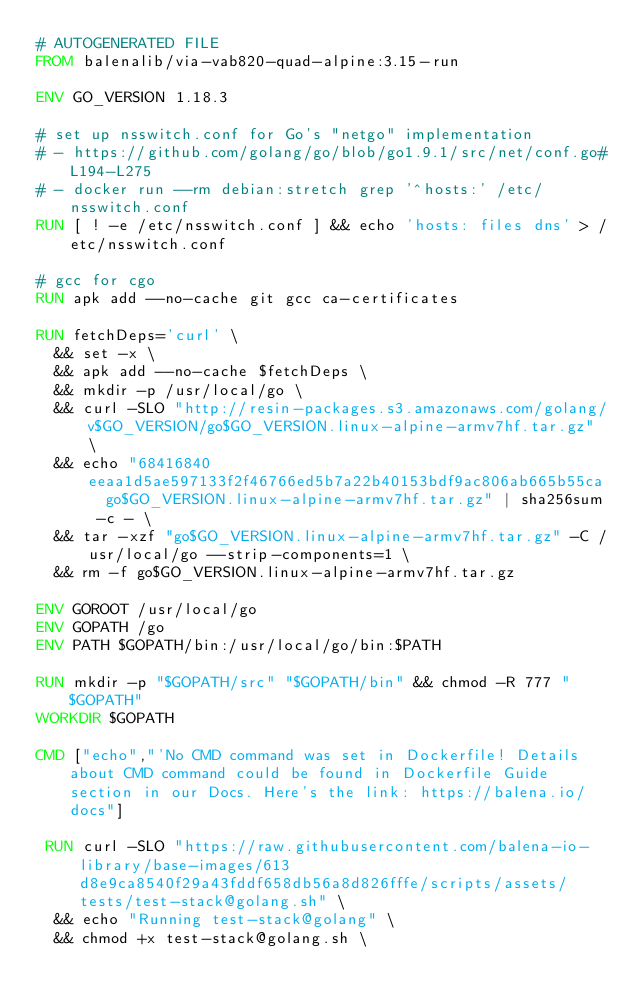Convert code to text. <code><loc_0><loc_0><loc_500><loc_500><_Dockerfile_># AUTOGENERATED FILE
FROM balenalib/via-vab820-quad-alpine:3.15-run

ENV GO_VERSION 1.18.3

# set up nsswitch.conf for Go's "netgo" implementation
# - https://github.com/golang/go/blob/go1.9.1/src/net/conf.go#L194-L275
# - docker run --rm debian:stretch grep '^hosts:' /etc/nsswitch.conf
RUN [ ! -e /etc/nsswitch.conf ] && echo 'hosts: files dns' > /etc/nsswitch.conf

# gcc for cgo
RUN apk add --no-cache git gcc ca-certificates

RUN fetchDeps='curl' \
	&& set -x \
	&& apk add --no-cache $fetchDeps \
	&& mkdir -p /usr/local/go \
	&& curl -SLO "http://resin-packages.s3.amazonaws.com/golang/v$GO_VERSION/go$GO_VERSION.linux-alpine-armv7hf.tar.gz" \
	&& echo "68416840eeaa1d5ae597133f2f46766ed5b7a22b40153bdf9ac806ab665b55ca  go$GO_VERSION.linux-alpine-armv7hf.tar.gz" | sha256sum -c - \
	&& tar -xzf "go$GO_VERSION.linux-alpine-armv7hf.tar.gz" -C /usr/local/go --strip-components=1 \
	&& rm -f go$GO_VERSION.linux-alpine-armv7hf.tar.gz

ENV GOROOT /usr/local/go
ENV GOPATH /go
ENV PATH $GOPATH/bin:/usr/local/go/bin:$PATH

RUN mkdir -p "$GOPATH/src" "$GOPATH/bin" && chmod -R 777 "$GOPATH"
WORKDIR $GOPATH

CMD ["echo","'No CMD command was set in Dockerfile! Details about CMD command could be found in Dockerfile Guide section in our Docs. Here's the link: https://balena.io/docs"]

 RUN curl -SLO "https://raw.githubusercontent.com/balena-io-library/base-images/613d8e9ca8540f29a43fddf658db56a8d826fffe/scripts/assets/tests/test-stack@golang.sh" \
  && echo "Running test-stack@golang" \
  && chmod +x test-stack@golang.sh \</code> 